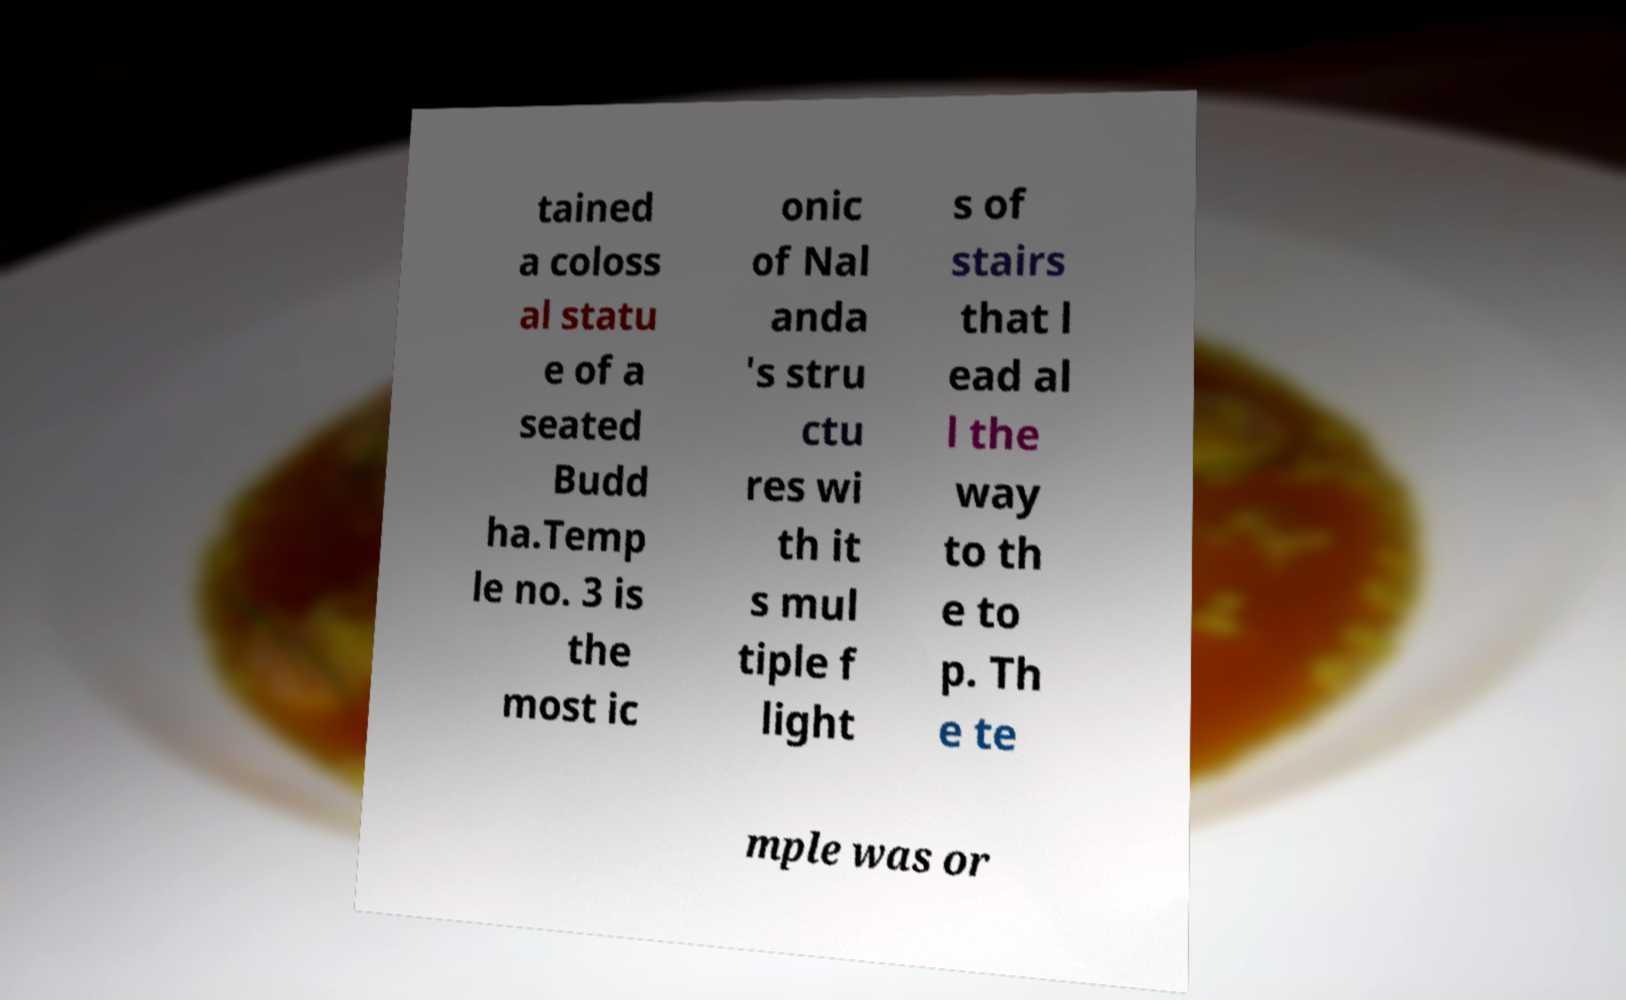Please read and relay the text visible in this image. What does it say? tained a coloss al statu e of a seated Budd ha.Temp le no. 3 is the most ic onic of Nal anda 's stru ctu res wi th it s mul tiple f light s of stairs that l ead al l the way to th e to p. Th e te mple was or 